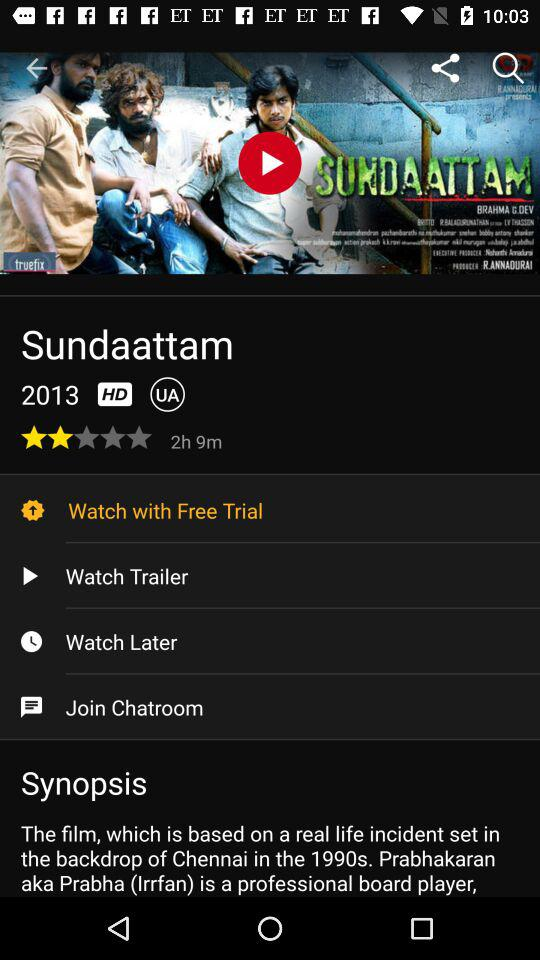What is the rating of the Sundaattam movie out of 5 stars? The rating is 2 stars. 